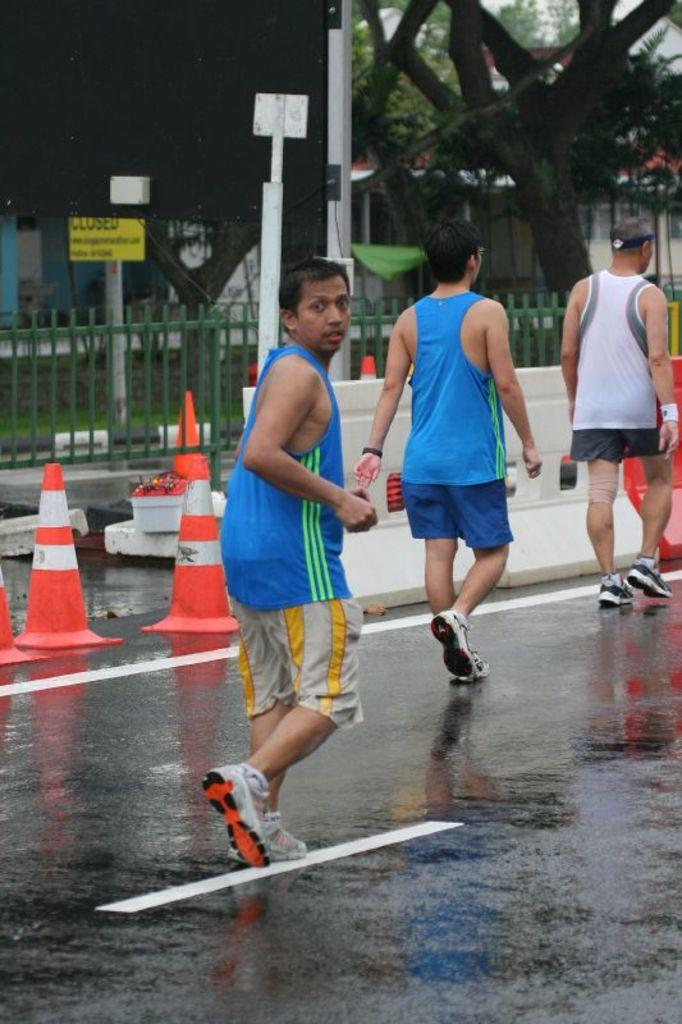What is the man in the image doing? The man is running in the image. What are the two people in the image doing? The two people are walking in the image. What objects are present on the road in the image? Traffic cones are present on the road in the image. What can be seen in the background of the image? In the background of the image, there is a fence, boards on poles, grass, trees, and a house. How many stones are visible in the image? There are no stones visible in the image. What type of flock is present in the image? There is no flock present in the image. 